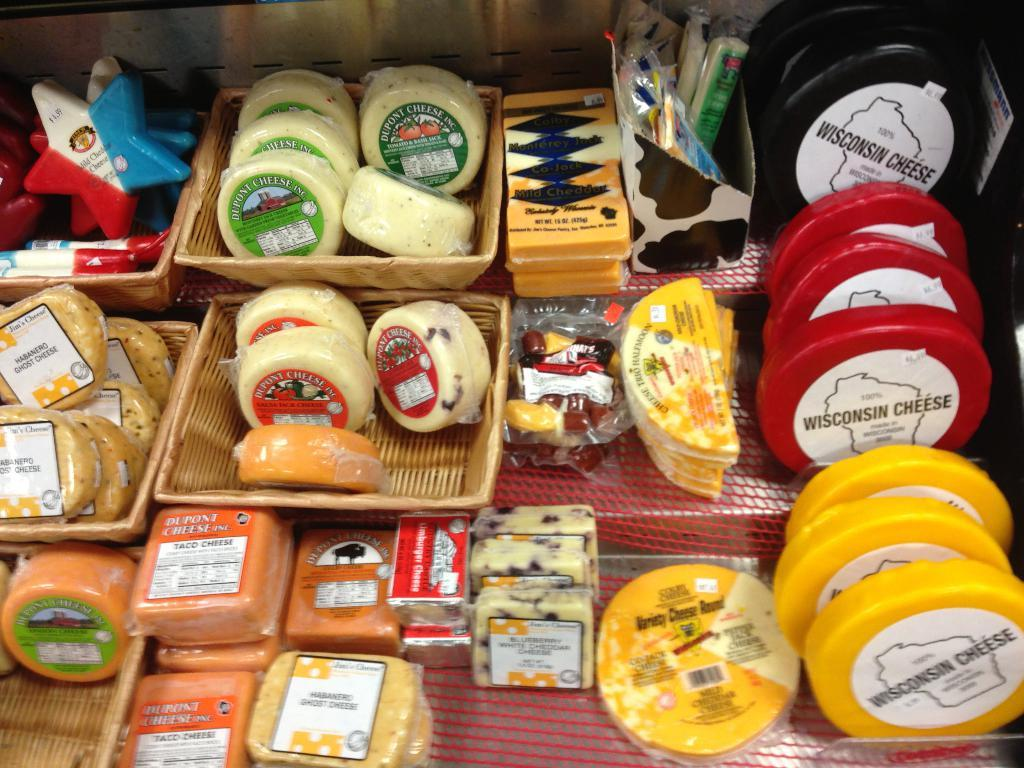<image>
Give a short and clear explanation of the subsequent image. Several varieties of cheese are on a shelf, including some from Wisconsin. 